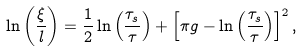Convert formula to latex. <formula><loc_0><loc_0><loc_500><loc_500>\ln \left ( \frac { \xi } { l } \right ) = \frac { 1 } { 2 } \ln \left ( \frac { \tau _ { s } } { \tau } \right ) + \left [ \pi g - \ln \left ( \frac { \tau _ { s } } { \tau } \right ) \right ] ^ { 2 } ,</formula> 